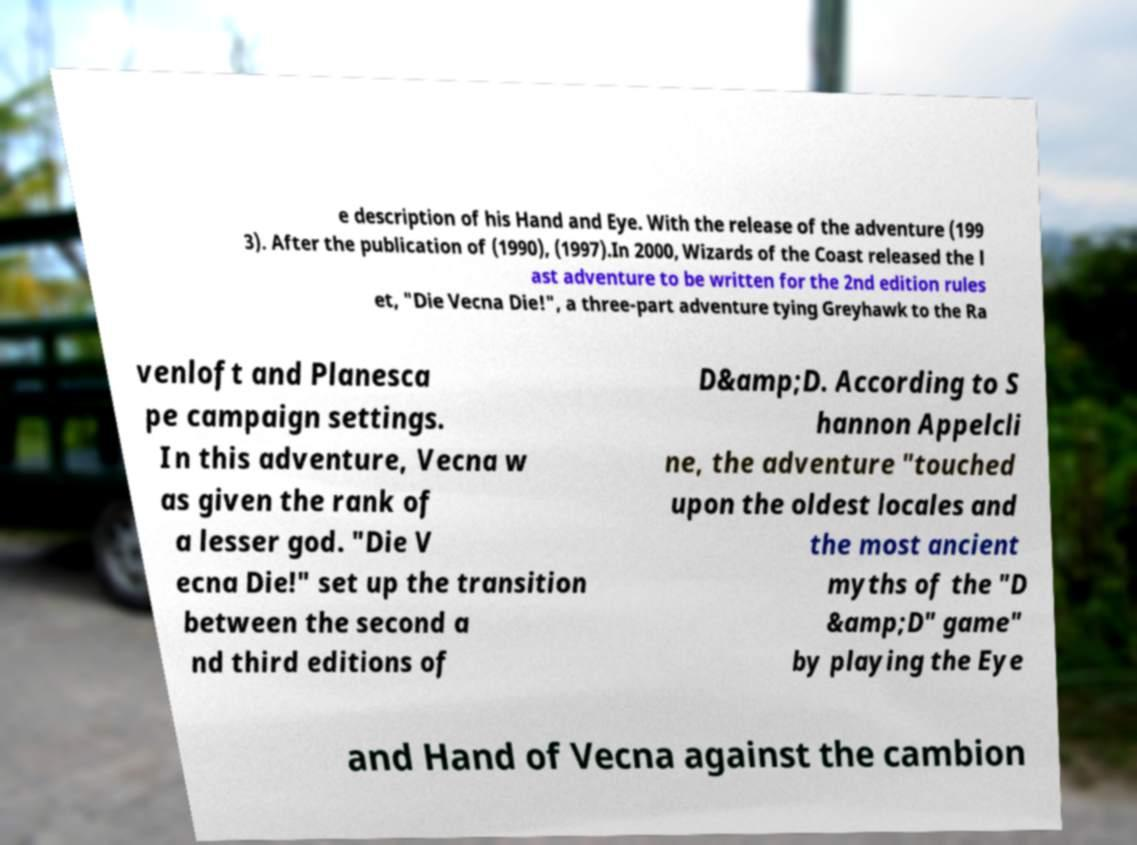Can you read and provide the text displayed in the image?This photo seems to have some interesting text. Can you extract and type it out for me? e description of his Hand and Eye. With the release of the adventure (199 3). After the publication of (1990), (1997).In 2000, Wizards of the Coast released the l ast adventure to be written for the 2nd edition rules et, "Die Vecna Die!", a three-part adventure tying Greyhawk to the Ra venloft and Planesca pe campaign settings. In this adventure, Vecna w as given the rank of a lesser god. "Die V ecna Die!" set up the transition between the second a nd third editions of D&amp;D. According to S hannon Appelcli ne, the adventure "touched upon the oldest locales and the most ancient myths of the "D &amp;D" game" by playing the Eye and Hand of Vecna against the cambion 